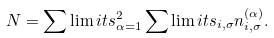<formula> <loc_0><loc_0><loc_500><loc_500>N = \sum \lim i t s _ { \alpha = 1 } ^ { 2 } \sum \lim i t s _ { i , \sigma } n _ { i , \sigma } ^ { ( \alpha ) } .</formula> 